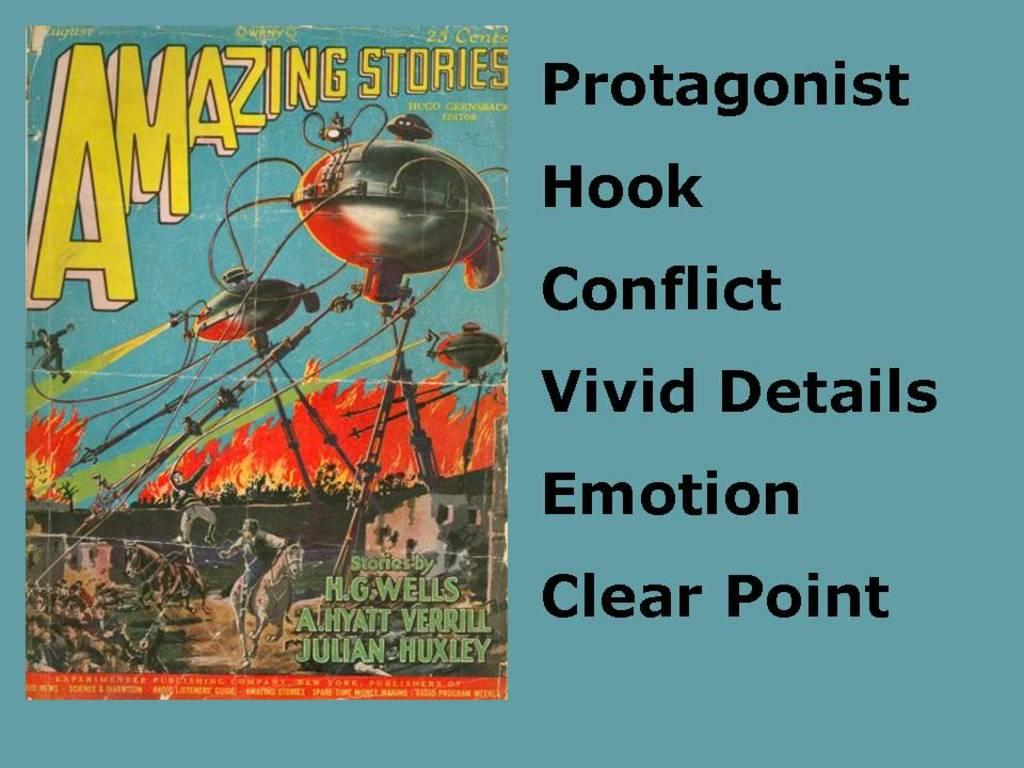What is the main subject of the poster in the image? The poster depicts machines and people fighting. Where is the text located on the poster? The text is written on the right side of the poster. What type of treatment is being administered to the people in the poster? There is no treatment being administered to the people in the poster, as it depicts a scene of machines and people fighting. What type of harmony is being portrayed in the poster? The poster does not depict harmony, as it shows machines and people fighting. 